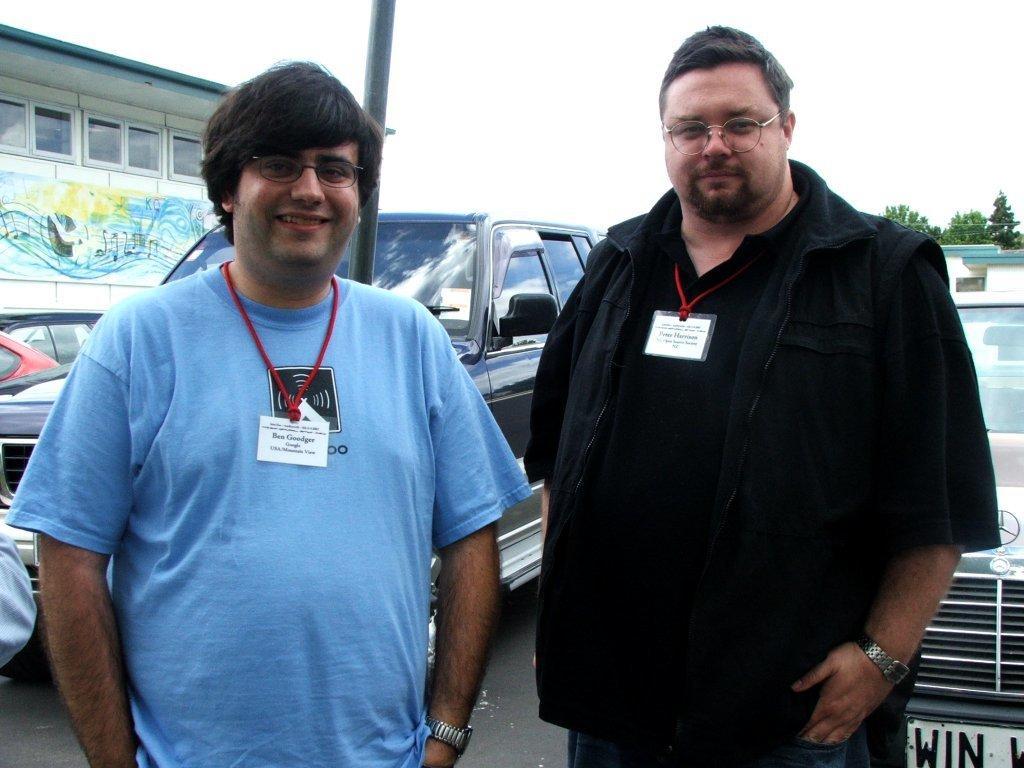Can you describe this image briefly? This picture shows couple of men standing and they wore id cards and spectacles on their faces and we see few cars parked and a building on the side and we see couple of trees and cloudy sky and we see a pole on the back. 